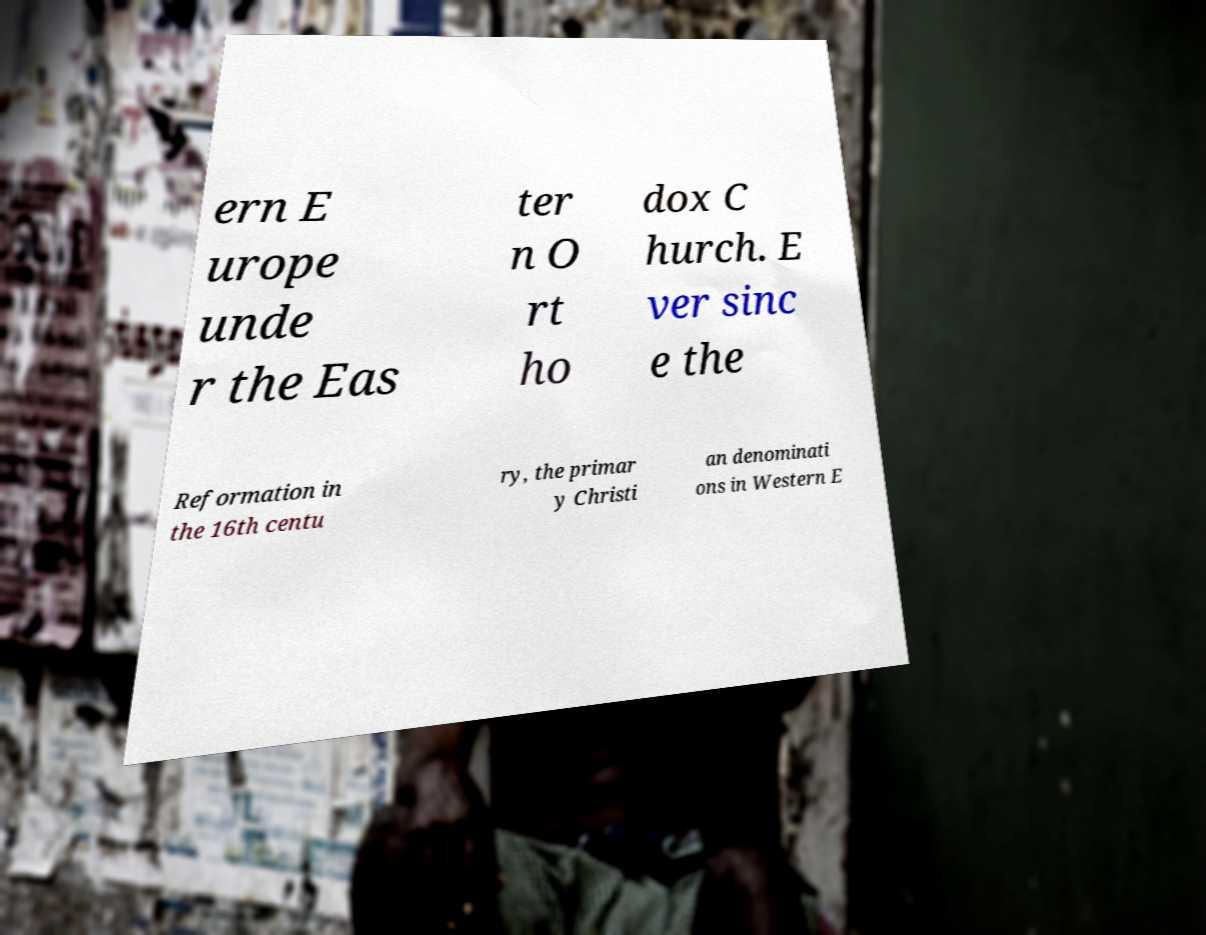I need the written content from this picture converted into text. Can you do that? ern E urope unde r the Eas ter n O rt ho dox C hurch. E ver sinc e the Reformation in the 16th centu ry, the primar y Christi an denominati ons in Western E 